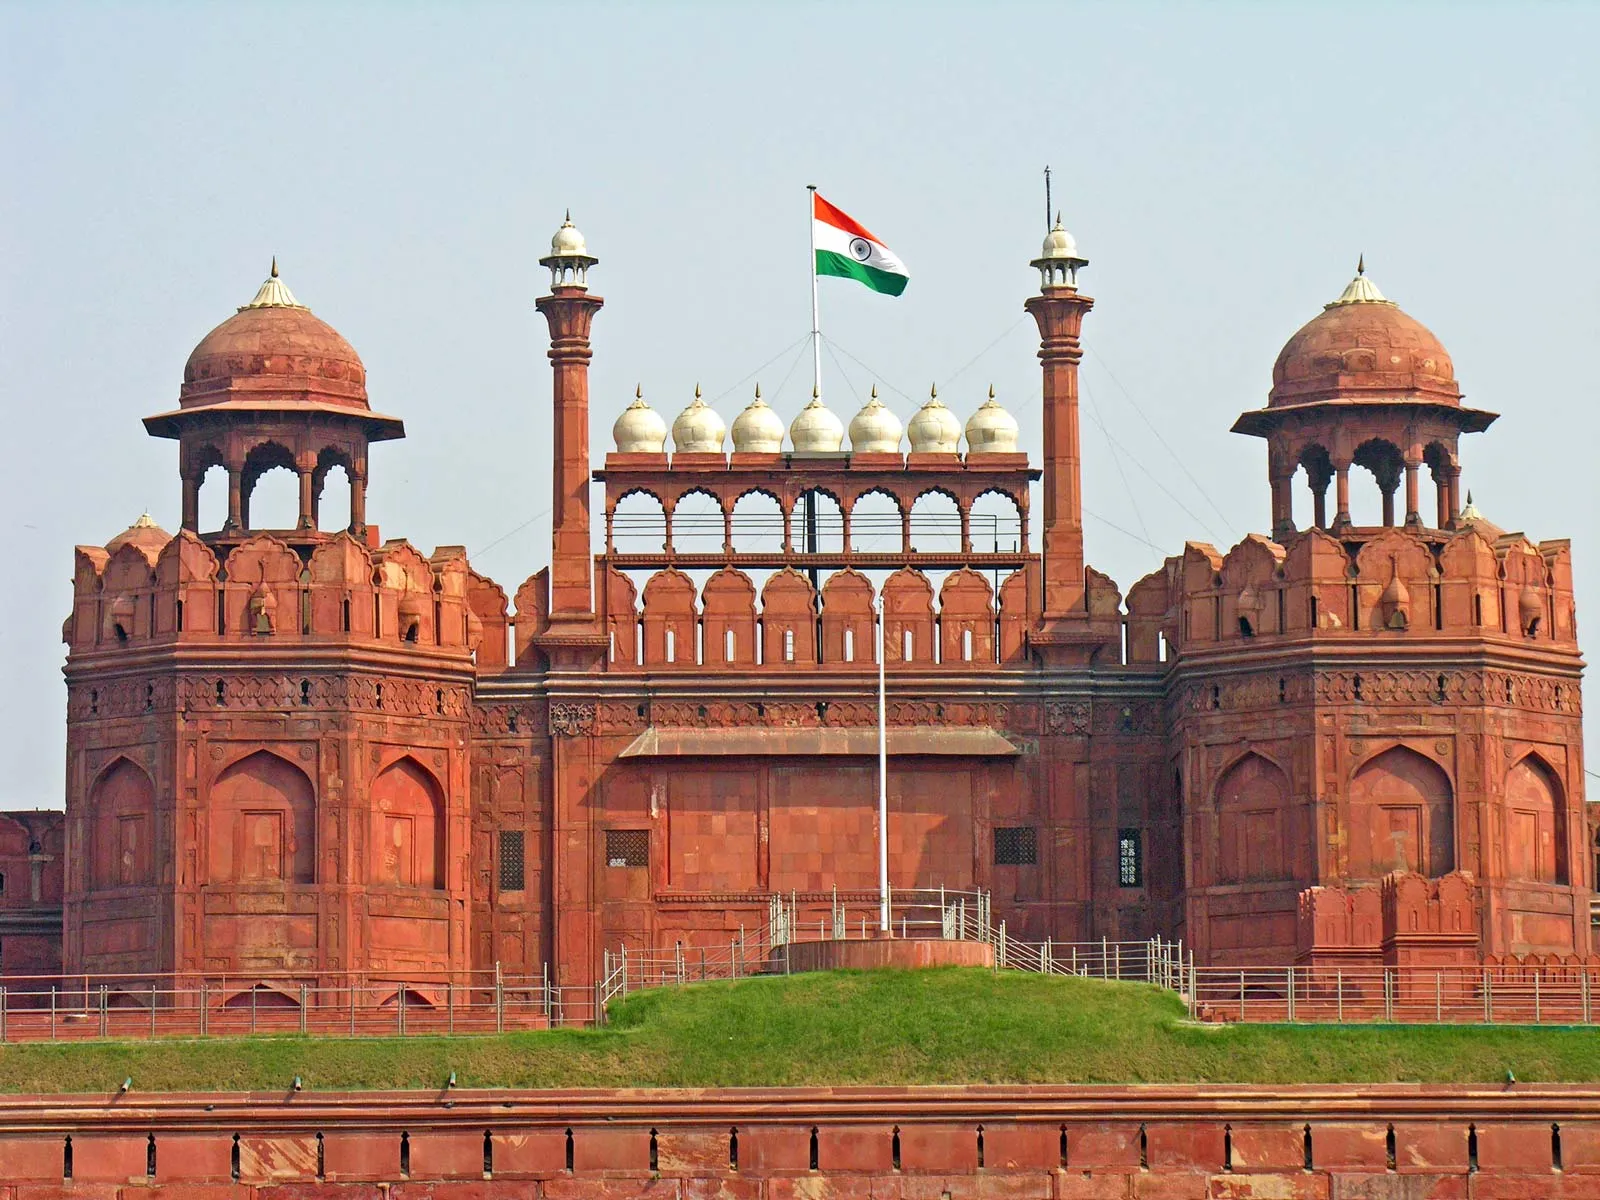If this fort could tell a story, what intriguing tale would it share? The Red Fort might tell tales of the Mughal emperors who resided within its walls, like Shah Jahan who commissioned its construction. One intriguing tale could be about the life within the royal harem, hidden from the outside world, teeming with politics and intrigue. It might recount the eventual fall of the Mughals to the British and the fort's transformation into a colonial administrative center. Stories of independence struggle leaders, like Mahatma Gandhi, giving speeches here and rallies held within its premises, would also make a compelling narrative. Each brick would whisper secrets of past battles, royal decrees, and historic milestones that have shaped modern India. Very creatively, what if this fort was taken over by a futuristic society? How would it look? In a futuristic society, the Red Fort could be transformed into a blend of historical architecture and advanced technology. Imagine the red sandstone walls reinforced with transparent, indestructible materials that change color with the time of day. The ancient domes could be retrofitted with solar panels, merging traditional design with energy sustainability. Holographic displays might narrate the history of the fort to visitors, while drones patrol the moat, ensuring security. The surrounding garden spaces could be home to genetically engineered plants that glow in the dark, creating a surreal nighttime spectacle. Inside, the rooms could be equipped with advanced AI assistants that give personalized historical tours and interactive experiences, bridging the past with the future in a unique, harmonious way.  How does the architectural design of the Red Fort reflect the culture and era it was built in? The Red Fort's architectural design is a reflection of Mughal grandeur and their love for art and aesthetics. The extensive use of red sandstone symbolizes strength and durability, while the intricate carvings and inlays reflect the skilled craftsmanship of the era. The symmetrical design and balanced proportions are indicative of the Mughal's emphasis on order and beauty. The fort incorporates elements of Persian, Timurid, and Indian architecture, showcasing the cultural amalgamation that defined the Mughal Empire.  Describe a day in the life of someone who lived in this fort during the Mughal era. A day in the life of a nobleman in the Red Fort during the Mughal era would begin with morning prayers at one of the fort's intricate mosques. This would be followed by a leisurely breakfast in one of the opulent courtyards, surrounded by the sound of fountains and the fragrance of blooming flowers. The nobleman might then attend court, engaging in discussions on politics, strategy, or culture under the emperor's watchful eyes. As the sun climbed higher, he could retire to the Diwan-i-Am, the hall for public audiences, or visit the hammam for a relaxing bath. Midday meals would be a grand affair, filled with exotic dishes and spices. The afternoon might be spent in artistic pursuits, like poetry, music, or calligraphy, or perhaps a stroll through the lush gardens. As evening approached, the nobleman would attend social gatherings or watch performances by dancers and musicians. The day would end with a quiet dinner under the starry sky on the terrace, reflecting on the day's events. 